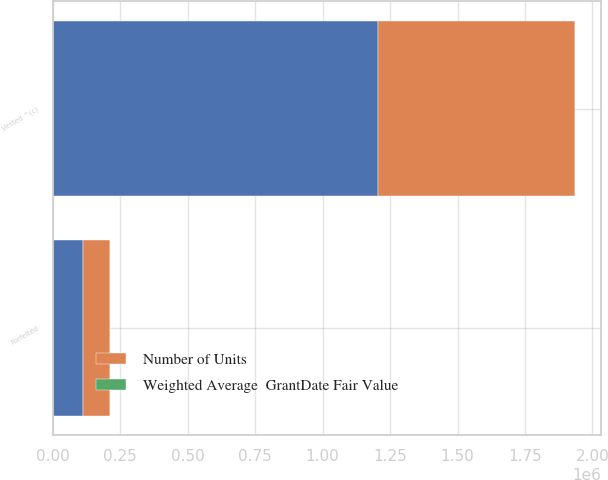Convert chart to OTSL. <chart><loc_0><loc_0><loc_500><loc_500><stacked_bar_chart><ecel><fcel>Vested ^(c)<fcel>Forfeited<nl><fcel>nan<fcel>1.20565e+06<fcel>113041<nl><fcel>Number of Units<fcel>728576<fcel>98509<nl><fcel>Weighted Average  GrantDate Fair Value<fcel>55.85<fcel>55.92<nl></chart> 